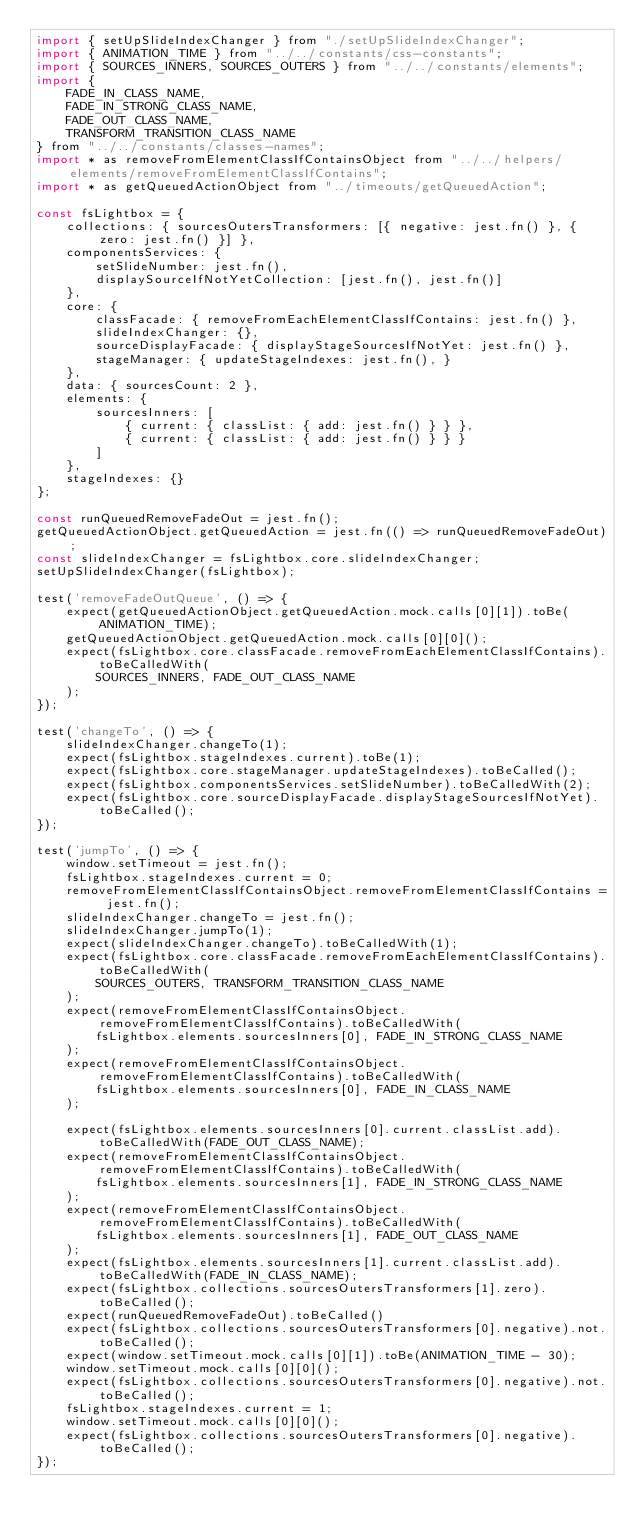<code> <loc_0><loc_0><loc_500><loc_500><_JavaScript_>import { setUpSlideIndexChanger } from "./setUpSlideIndexChanger";
import { ANIMATION_TIME } from "../../constants/css-constants";
import { SOURCES_INNERS, SOURCES_OUTERS } from "../../constants/elements";
import {
    FADE_IN_CLASS_NAME,
    FADE_IN_STRONG_CLASS_NAME,
    FADE_OUT_CLASS_NAME,
    TRANSFORM_TRANSITION_CLASS_NAME
} from "../../constants/classes-names";
import * as removeFromElementClassIfContainsObject from "../../helpers/elements/removeFromElementClassIfContains";
import * as getQueuedActionObject from "../timeouts/getQueuedAction";

const fsLightbox = {
    collections: { sourcesOutersTransformers: [{ negative: jest.fn() }, { zero: jest.fn() }] },
    componentsServices: {
        setSlideNumber: jest.fn(),
        displaySourceIfNotYetCollection: [jest.fn(), jest.fn()]
    },
    core: {
        classFacade: { removeFromEachElementClassIfContains: jest.fn() },
        slideIndexChanger: {},
        sourceDisplayFacade: { displayStageSourcesIfNotYet: jest.fn() },
        stageManager: { updateStageIndexes: jest.fn(), }
    },
    data: { sourcesCount: 2 },
    elements: {
        sourcesInners: [
            { current: { classList: { add: jest.fn() } } },
            { current: { classList: { add: jest.fn() } } }
        ]
    },
    stageIndexes: {}
};

const runQueuedRemoveFadeOut = jest.fn();
getQueuedActionObject.getQueuedAction = jest.fn(() => runQueuedRemoveFadeOut);
const slideIndexChanger = fsLightbox.core.slideIndexChanger;
setUpSlideIndexChanger(fsLightbox);

test('removeFadeOutQueue', () => {
    expect(getQueuedActionObject.getQueuedAction.mock.calls[0][1]).toBe(ANIMATION_TIME);
    getQueuedActionObject.getQueuedAction.mock.calls[0][0]();
    expect(fsLightbox.core.classFacade.removeFromEachElementClassIfContains).toBeCalledWith(
        SOURCES_INNERS, FADE_OUT_CLASS_NAME
    );
});

test('changeTo', () => {
    slideIndexChanger.changeTo(1);
    expect(fsLightbox.stageIndexes.current).toBe(1);
    expect(fsLightbox.core.stageManager.updateStageIndexes).toBeCalled();
    expect(fsLightbox.componentsServices.setSlideNumber).toBeCalledWith(2);
    expect(fsLightbox.core.sourceDisplayFacade.displayStageSourcesIfNotYet).toBeCalled();
});

test('jumpTo', () => {
    window.setTimeout = jest.fn();
    fsLightbox.stageIndexes.current = 0;
    removeFromElementClassIfContainsObject.removeFromElementClassIfContains = jest.fn();
    slideIndexChanger.changeTo = jest.fn();
    slideIndexChanger.jumpTo(1);
    expect(slideIndexChanger.changeTo).toBeCalledWith(1);
    expect(fsLightbox.core.classFacade.removeFromEachElementClassIfContains).toBeCalledWith(
        SOURCES_OUTERS, TRANSFORM_TRANSITION_CLASS_NAME
    );
    expect(removeFromElementClassIfContainsObject.removeFromElementClassIfContains).toBeCalledWith(
        fsLightbox.elements.sourcesInners[0], FADE_IN_STRONG_CLASS_NAME
    );
    expect(removeFromElementClassIfContainsObject.removeFromElementClassIfContains).toBeCalledWith(
        fsLightbox.elements.sourcesInners[0], FADE_IN_CLASS_NAME
    );

    expect(fsLightbox.elements.sourcesInners[0].current.classList.add).toBeCalledWith(FADE_OUT_CLASS_NAME);
    expect(removeFromElementClassIfContainsObject.removeFromElementClassIfContains).toBeCalledWith(
        fsLightbox.elements.sourcesInners[1], FADE_IN_STRONG_CLASS_NAME
    );
    expect(removeFromElementClassIfContainsObject.removeFromElementClassIfContains).toBeCalledWith(
        fsLightbox.elements.sourcesInners[1], FADE_OUT_CLASS_NAME
    );
    expect(fsLightbox.elements.sourcesInners[1].current.classList.add).toBeCalledWith(FADE_IN_CLASS_NAME);
    expect(fsLightbox.collections.sourcesOutersTransformers[1].zero).toBeCalled();
    expect(runQueuedRemoveFadeOut).toBeCalled()
    expect(fsLightbox.collections.sourcesOutersTransformers[0].negative).not.toBeCalled();
    expect(window.setTimeout.mock.calls[0][1]).toBe(ANIMATION_TIME - 30);
    window.setTimeout.mock.calls[0][0]();
    expect(fsLightbox.collections.sourcesOutersTransformers[0].negative).not.toBeCalled();
    fsLightbox.stageIndexes.current = 1;
    window.setTimeout.mock.calls[0][0]();
    expect(fsLightbox.collections.sourcesOutersTransformers[0].negative).toBeCalled();
});
</code> 